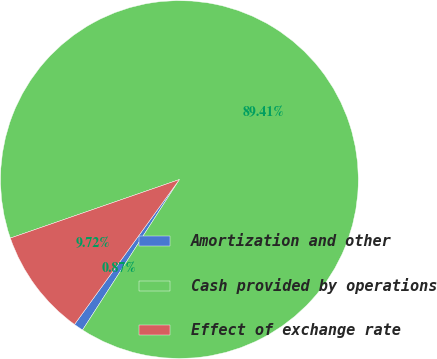Convert chart. <chart><loc_0><loc_0><loc_500><loc_500><pie_chart><fcel>Amortization and other<fcel>Cash provided by operations<fcel>Effect of exchange rate<nl><fcel>0.87%<fcel>89.41%<fcel>9.72%<nl></chart> 